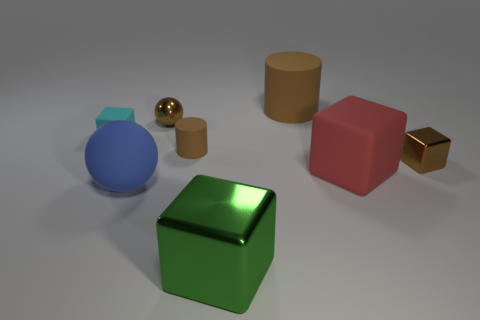Subtract all blue balls. How many balls are left? 1 Subtract all tiny brown cubes. How many cubes are left? 3 Subtract all large blue things. Subtract all small brown metal blocks. How many objects are left? 6 Add 1 big red matte things. How many big red matte things are left? 2 Add 2 green matte balls. How many green matte balls exist? 2 Add 1 rubber spheres. How many objects exist? 9 Subtract 0 blue cubes. How many objects are left? 8 Subtract all spheres. How many objects are left? 6 Subtract 4 blocks. How many blocks are left? 0 Subtract all red cylinders. Subtract all gray blocks. How many cylinders are left? 2 